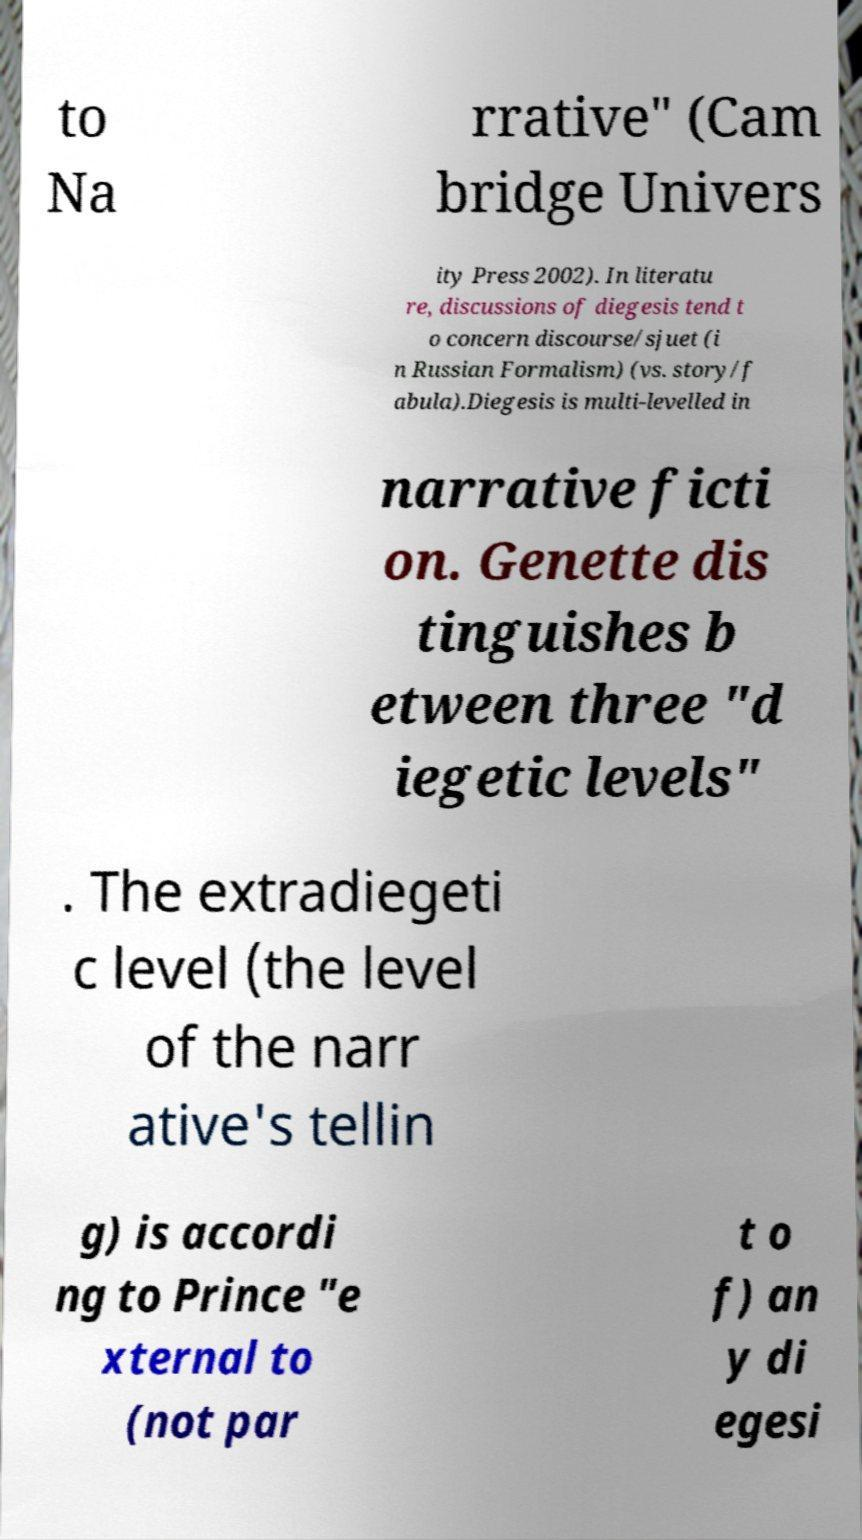For documentation purposes, I need the text within this image transcribed. Could you provide that? to Na rrative" (Cam bridge Univers ity Press 2002). In literatu re, discussions of diegesis tend t o concern discourse/sjuet (i n Russian Formalism) (vs. story/f abula).Diegesis is multi-levelled in narrative ficti on. Genette dis tinguishes b etween three "d iegetic levels" . The extradiegeti c level (the level of the narr ative's tellin g) is accordi ng to Prince "e xternal to (not par t o f) an y di egesi 